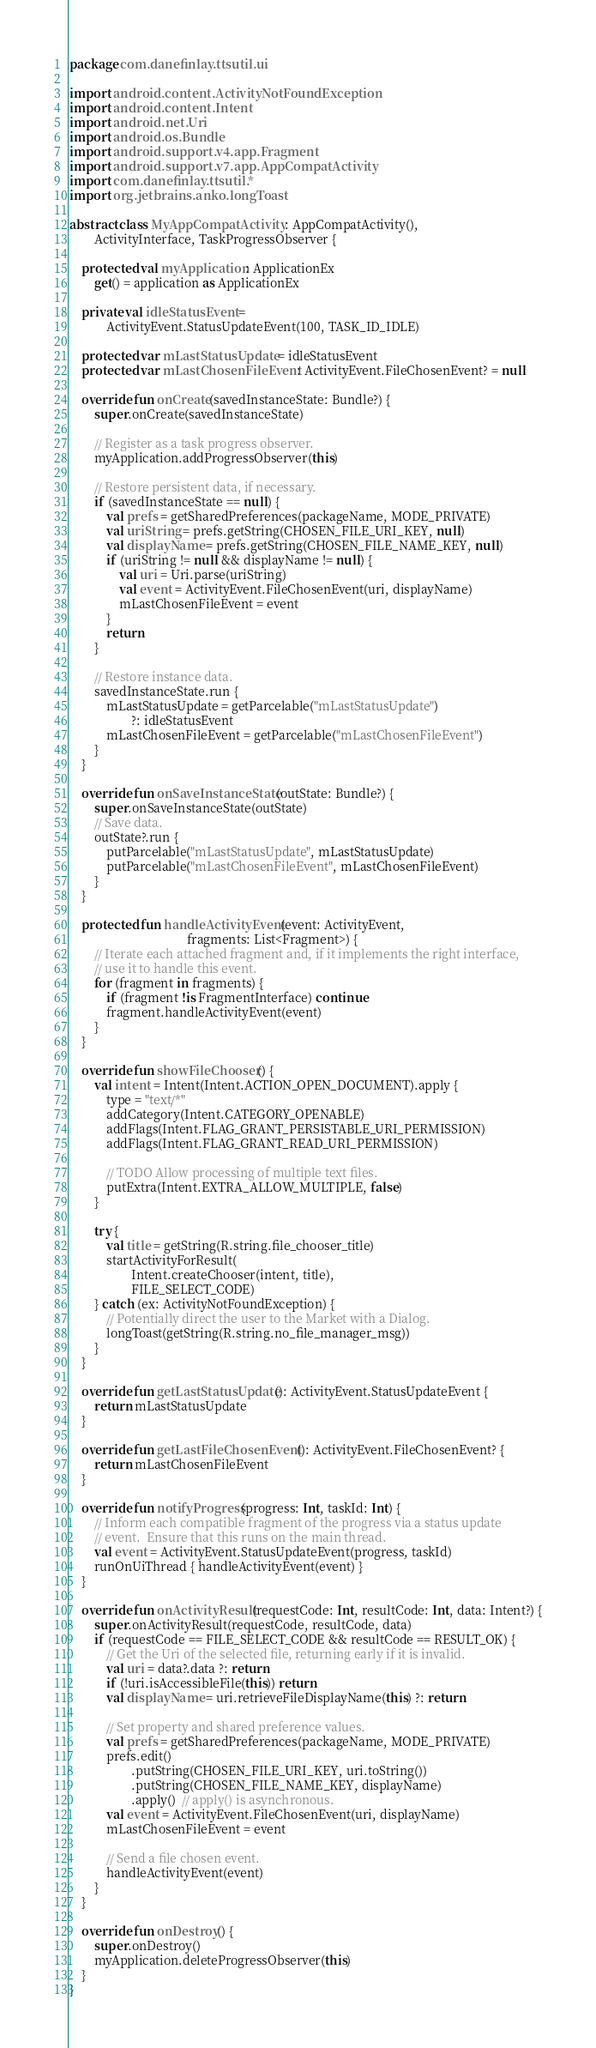<code> <loc_0><loc_0><loc_500><loc_500><_Kotlin_>package com.danefinlay.ttsutil.ui

import android.content.ActivityNotFoundException
import android.content.Intent
import android.net.Uri
import android.os.Bundle
import android.support.v4.app.Fragment
import android.support.v7.app.AppCompatActivity
import com.danefinlay.ttsutil.*
import org.jetbrains.anko.longToast

abstract class MyAppCompatActivity : AppCompatActivity(),
        ActivityInterface, TaskProgressObserver {

    protected val myApplication: ApplicationEx
        get() = application as ApplicationEx

    private val idleStatusEvent =
            ActivityEvent.StatusUpdateEvent(100, TASK_ID_IDLE)

    protected var mLastStatusUpdate = idleStatusEvent
    protected var mLastChosenFileEvent: ActivityEvent.FileChosenEvent? = null

    override fun onCreate(savedInstanceState: Bundle?) {
        super.onCreate(savedInstanceState)

        // Register as a task progress observer.
        myApplication.addProgressObserver(this)

        // Restore persistent data, if necessary.
        if (savedInstanceState == null) {
            val prefs = getSharedPreferences(packageName, MODE_PRIVATE)
            val uriString = prefs.getString(CHOSEN_FILE_URI_KEY, null)
            val displayName = prefs.getString(CHOSEN_FILE_NAME_KEY, null)
            if (uriString != null && displayName != null) {
                val uri = Uri.parse(uriString)
                val event = ActivityEvent.FileChosenEvent(uri, displayName)
                mLastChosenFileEvent = event
            }
            return
        }

        // Restore instance data.
        savedInstanceState.run {
            mLastStatusUpdate = getParcelable("mLastStatusUpdate")
                    ?: idleStatusEvent
            mLastChosenFileEvent = getParcelable("mLastChosenFileEvent")
        }
    }

    override fun onSaveInstanceState(outState: Bundle?) {
        super.onSaveInstanceState(outState)
        // Save data.
        outState?.run {
            putParcelable("mLastStatusUpdate", mLastStatusUpdate)
            putParcelable("mLastChosenFileEvent", mLastChosenFileEvent)
        }
    }

    protected fun handleActivityEvent(event: ActivityEvent,
                                      fragments: List<Fragment>) {
        // Iterate each attached fragment and, if it implements the right interface,
        // use it to handle this event.
        for (fragment in fragments) {
            if (fragment !is FragmentInterface) continue
            fragment.handleActivityEvent(event)
        }
    }

    override fun showFileChooser() {
        val intent = Intent(Intent.ACTION_OPEN_DOCUMENT).apply {
            type = "text/*"
            addCategory(Intent.CATEGORY_OPENABLE)
            addFlags(Intent.FLAG_GRANT_PERSISTABLE_URI_PERMISSION)
            addFlags(Intent.FLAG_GRANT_READ_URI_PERMISSION)

            // TODO Allow processing of multiple text files.
            putExtra(Intent.EXTRA_ALLOW_MULTIPLE, false)
        }

        try {
            val title = getString(R.string.file_chooser_title)
            startActivityForResult(
                    Intent.createChooser(intent, title),
                    FILE_SELECT_CODE)
        } catch (ex: ActivityNotFoundException) {
            // Potentially direct the user to the Market with a Dialog.
            longToast(getString(R.string.no_file_manager_msg))
        }
    }

    override fun getLastStatusUpdate(): ActivityEvent.StatusUpdateEvent {
        return mLastStatusUpdate
    }

    override fun getLastFileChosenEvent(): ActivityEvent.FileChosenEvent? {
        return mLastChosenFileEvent
    }

    override fun notifyProgress(progress: Int, taskId: Int) {
        // Inform each compatible fragment of the progress via a status update
        // event.  Ensure that this runs on the main thread.
        val event = ActivityEvent.StatusUpdateEvent(progress, taskId)
        runOnUiThread { handleActivityEvent(event) }
    }

    override fun onActivityResult(requestCode: Int, resultCode: Int, data: Intent?) {
        super.onActivityResult(requestCode, resultCode, data)
        if (requestCode == FILE_SELECT_CODE && resultCode == RESULT_OK) {
            // Get the Uri of the selected file, returning early if it is invalid.
            val uri = data?.data ?: return
            if (!uri.isAccessibleFile(this)) return
            val displayName = uri.retrieveFileDisplayName(this) ?: return

            // Set property and shared preference values.
            val prefs = getSharedPreferences(packageName, MODE_PRIVATE)
            prefs.edit()
                    .putString(CHOSEN_FILE_URI_KEY, uri.toString())
                    .putString(CHOSEN_FILE_NAME_KEY, displayName)
                    .apply()  // apply() is asynchronous.
            val event = ActivityEvent.FileChosenEvent(uri, displayName)
            mLastChosenFileEvent = event

            // Send a file chosen event.
            handleActivityEvent(event)
        }
    }

    override fun onDestroy() {
        super.onDestroy()
        myApplication.deleteProgressObserver(this)
    }
}
</code> 